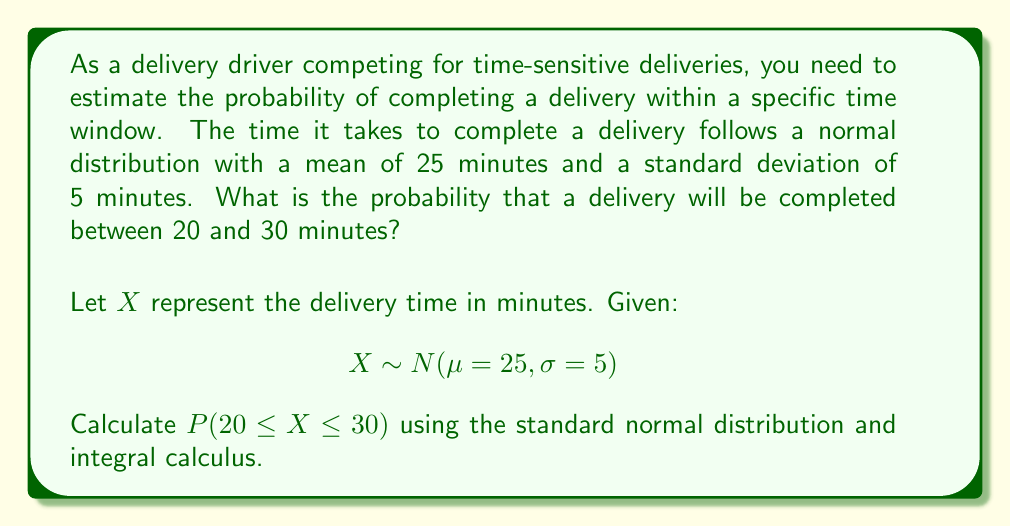Show me your answer to this math problem. To solve this problem, we'll follow these steps:

1) First, we need to standardize the normal distribution. The standard normal distribution has a mean of 0 and a standard deviation of 1. We can convert our X to a standard normal Z using the formula:

   $Z = \frac{X - \mu}{\sigma}$

2) We need to find $P(20 \leq X \leq 30)$, which is equivalent to:

   $P(\frac{20 - 25}{5} \leq Z \leq \frac{30 - 25}{5})$

3) Simplifying:

   $P(-1 \leq Z \leq 1)$

4) For a standard normal distribution, this probability can be calculated using the cumulative distribution function (CDF) Φ(z):

   $P(-1 \leq Z \leq 1) = \Phi(1) - \Phi(-1)$

5) The CDF of the standard normal distribution is given by the integral:

   $\Phi(z) = \frac{1}{\sqrt{2\pi}} \int_{-\infty}^{z} e^{-\frac{t^2}{2}} dt$

6) Therefore, our probability is:

   $P(-1 \leq Z \leq 1) = \frac{1}{\sqrt{2\pi}} \int_{-1}^{1} e^{-\frac{t^2}{2}} dt$

7) This integral doesn't have a closed-form solution, but it can be evaluated numerically. The result is approximately 0.6827.

This means there's about a 68.27% chance that a delivery will be completed between 20 and 30 minutes.
Answer: The probability that a delivery will be completed between 20 and 30 minutes is approximately 0.6827 or 68.27%. 